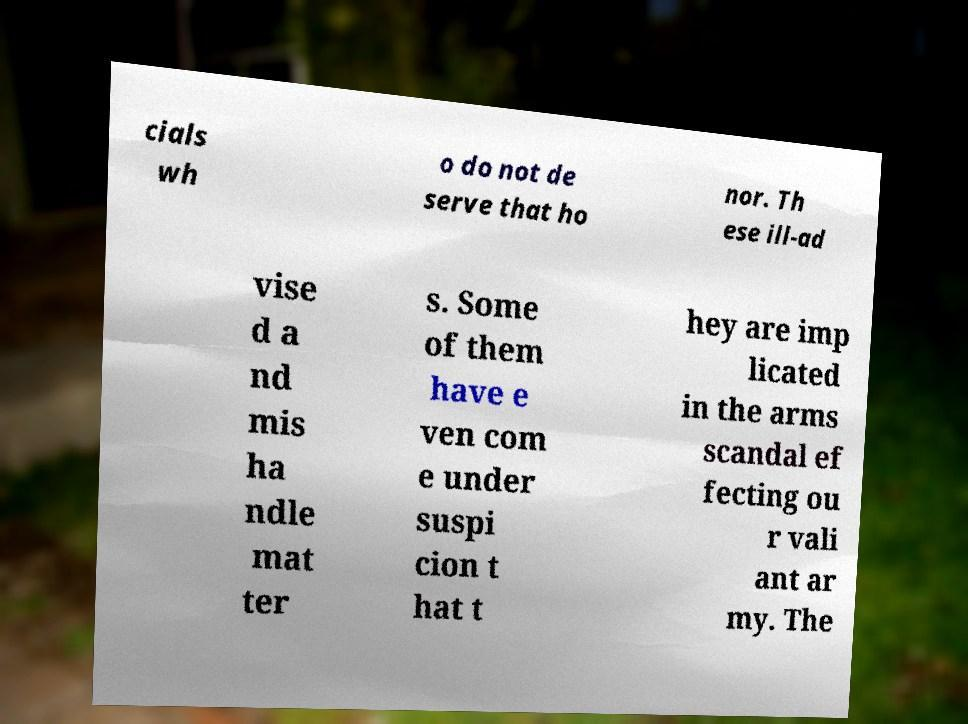Could you extract and type out the text from this image? cials wh o do not de serve that ho nor. Th ese ill-ad vise d a nd mis ha ndle mat ter s. Some of them have e ven com e under suspi cion t hat t hey are imp licated in the arms scandal ef fecting ou r vali ant ar my. The 